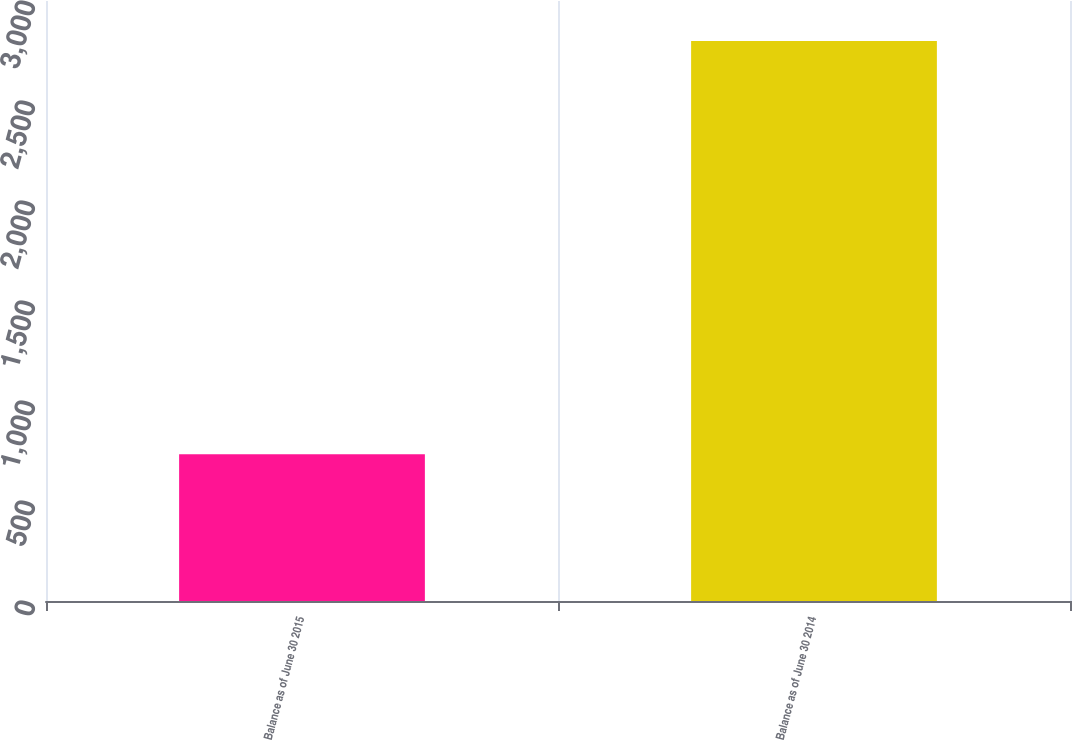<chart> <loc_0><loc_0><loc_500><loc_500><bar_chart><fcel>Balance as of June 30 2015<fcel>Balance as of June 30 2014<nl><fcel>734<fcel>2800<nl></chart> 